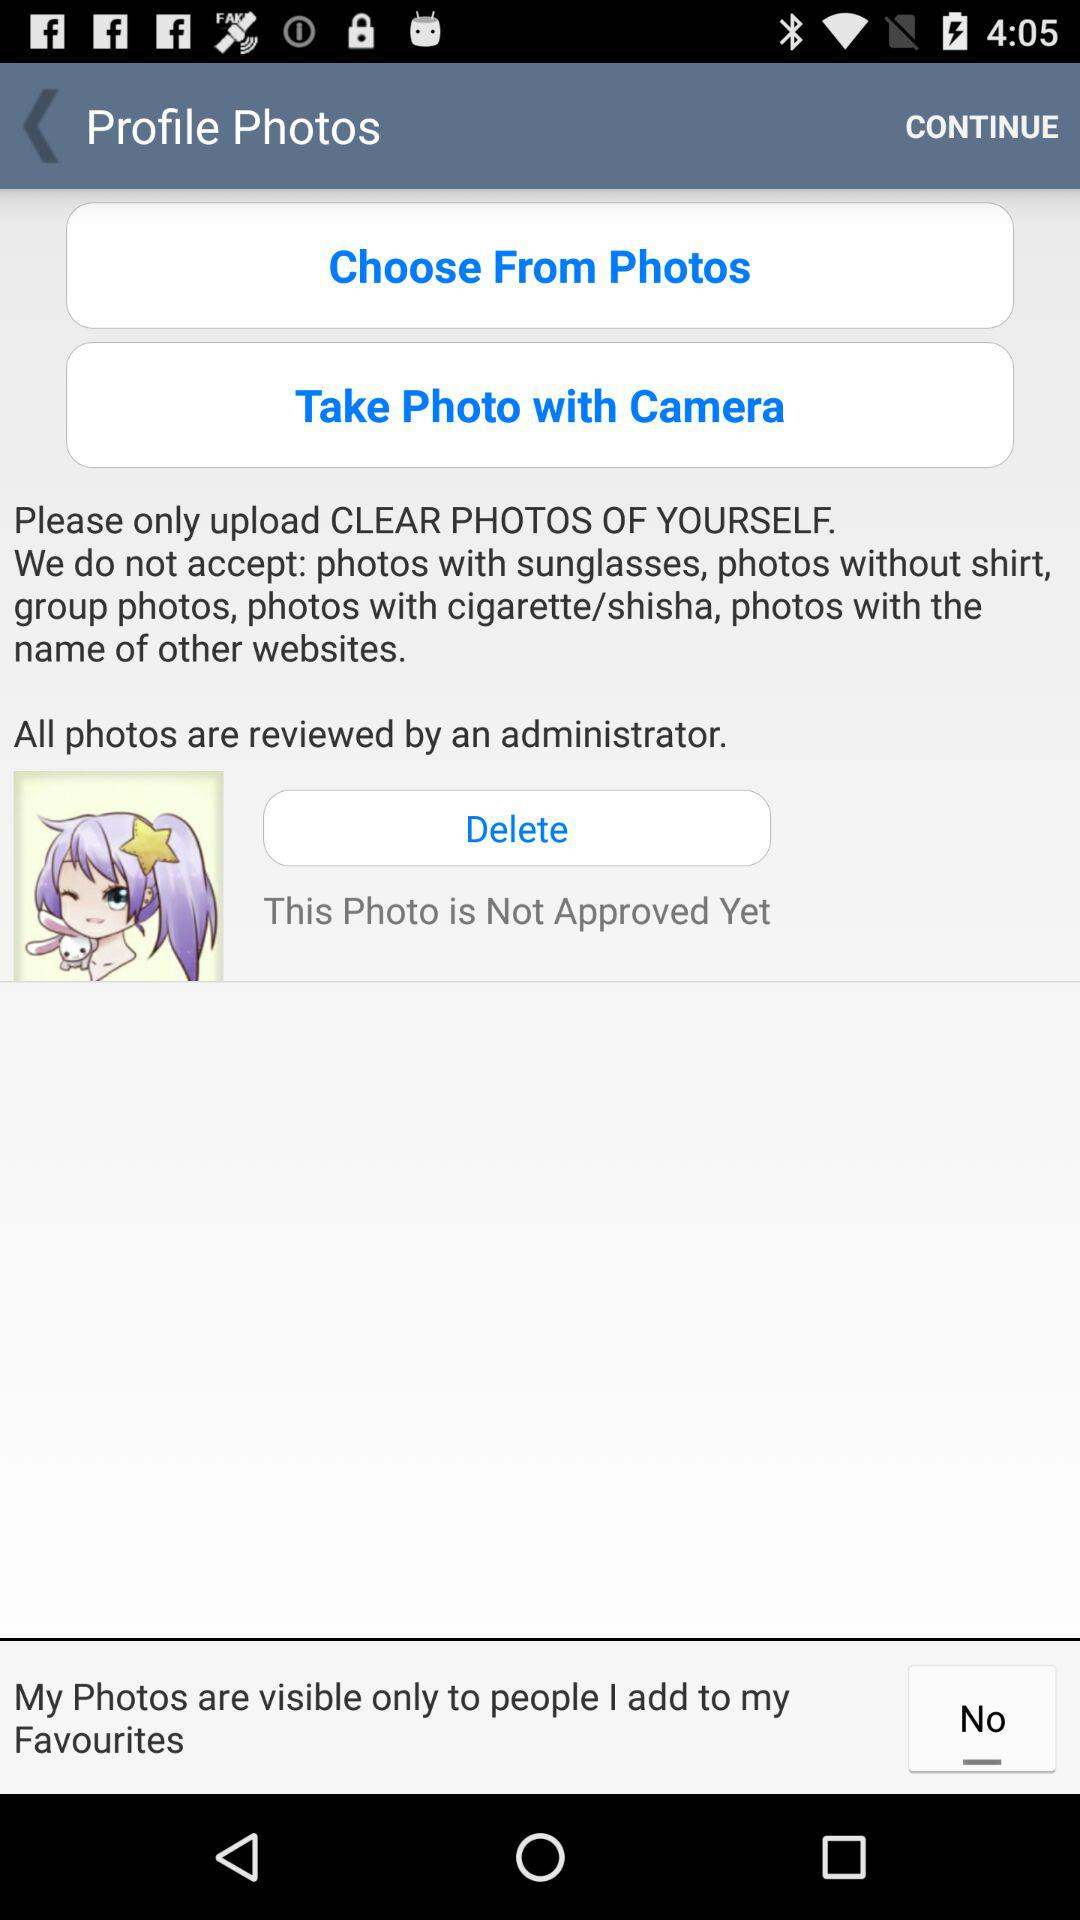When will the photo be approved?
When the provided information is insufficient, respond with <no answer>. <no answer> 